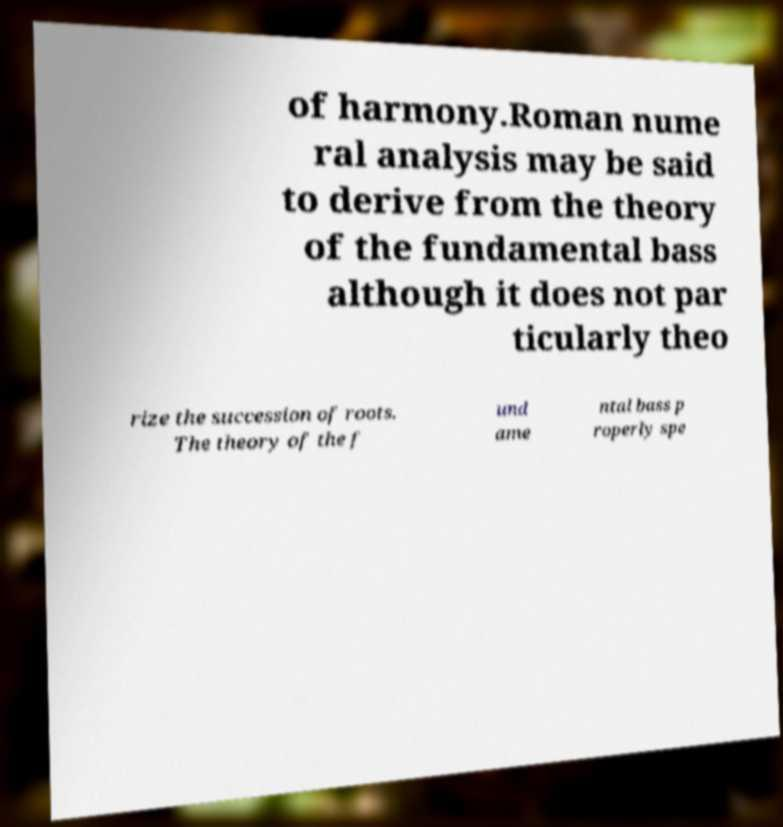I need the written content from this picture converted into text. Can you do that? of harmony.Roman nume ral analysis may be said to derive from the theory of the fundamental bass although it does not par ticularly theo rize the succession of roots. The theory of the f und ame ntal bass p roperly spe 